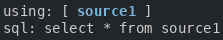<code> <loc_0><loc_0><loc_500><loc_500><_YAML_>using: [ source1 ]
sql: select * from source1</code> 